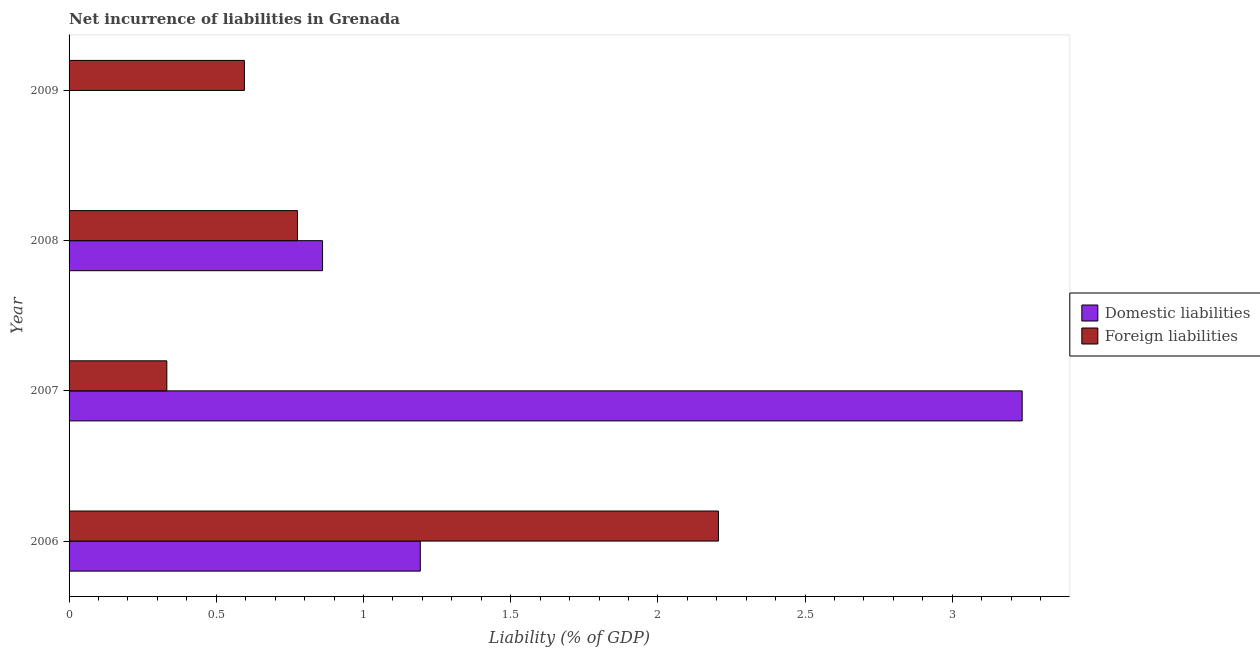How many bars are there on the 1st tick from the top?
Provide a short and direct response. 1. How many bars are there on the 2nd tick from the bottom?
Your response must be concise. 2. What is the label of the 4th group of bars from the top?
Provide a short and direct response. 2006. In how many cases, is the number of bars for a given year not equal to the number of legend labels?
Ensure brevity in your answer.  1. What is the incurrence of foreign liabilities in 2007?
Your answer should be compact. 0.33. Across all years, what is the maximum incurrence of domestic liabilities?
Keep it short and to the point. 3.24. Across all years, what is the minimum incurrence of foreign liabilities?
Your response must be concise. 0.33. In which year was the incurrence of domestic liabilities maximum?
Keep it short and to the point. 2007. What is the total incurrence of foreign liabilities in the graph?
Your answer should be compact. 3.91. What is the difference between the incurrence of foreign liabilities in 2008 and that in 2009?
Provide a short and direct response. 0.18. What is the difference between the incurrence of domestic liabilities in 2006 and the incurrence of foreign liabilities in 2009?
Give a very brief answer. 0.6. What is the average incurrence of foreign liabilities per year?
Offer a very short reply. 0.98. In the year 2008, what is the difference between the incurrence of foreign liabilities and incurrence of domestic liabilities?
Your response must be concise. -0.09. What is the ratio of the incurrence of domestic liabilities in 2006 to that in 2008?
Ensure brevity in your answer.  1.39. What is the difference between the highest and the second highest incurrence of domestic liabilities?
Your answer should be compact. 2.04. What is the difference between the highest and the lowest incurrence of domestic liabilities?
Ensure brevity in your answer.  3.24. Are all the bars in the graph horizontal?
Your answer should be compact. Yes. Are the values on the major ticks of X-axis written in scientific E-notation?
Provide a succinct answer. No. Does the graph contain grids?
Make the answer very short. No. How many legend labels are there?
Provide a short and direct response. 2. How are the legend labels stacked?
Make the answer very short. Vertical. What is the title of the graph?
Offer a terse response. Net incurrence of liabilities in Grenada. Does "Male" appear as one of the legend labels in the graph?
Give a very brief answer. No. What is the label or title of the X-axis?
Give a very brief answer. Liability (% of GDP). What is the Liability (% of GDP) of Domestic liabilities in 2006?
Offer a very short reply. 1.19. What is the Liability (% of GDP) of Foreign liabilities in 2006?
Offer a very short reply. 2.21. What is the Liability (% of GDP) of Domestic liabilities in 2007?
Keep it short and to the point. 3.24. What is the Liability (% of GDP) of Foreign liabilities in 2007?
Provide a succinct answer. 0.33. What is the Liability (% of GDP) of Domestic liabilities in 2008?
Your response must be concise. 0.86. What is the Liability (% of GDP) of Foreign liabilities in 2008?
Offer a terse response. 0.78. What is the Liability (% of GDP) in Foreign liabilities in 2009?
Give a very brief answer. 0.6. Across all years, what is the maximum Liability (% of GDP) of Domestic liabilities?
Your response must be concise. 3.24. Across all years, what is the maximum Liability (% of GDP) in Foreign liabilities?
Make the answer very short. 2.21. Across all years, what is the minimum Liability (% of GDP) of Foreign liabilities?
Your answer should be compact. 0.33. What is the total Liability (% of GDP) in Domestic liabilities in the graph?
Ensure brevity in your answer.  5.29. What is the total Liability (% of GDP) of Foreign liabilities in the graph?
Provide a short and direct response. 3.91. What is the difference between the Liability (% of GDP) of Domestic liabilities in 2006 and that in 2007?
Give a very brief answer. -2.04. What is the difference between the Liability (% of GDP) in Foreign liabilities in 2006 and that in 2007?
Give a very brief answer. 1.87. What is the difference between the Liability (% of GDP) in Domestic liabilities in 2006 and that in 2008?
Provide a short and direct response. 0.33. What is the difference between the Liability (% of GDP) in Foreign liabilities in 2006 and that in 2008?
Ensure brevity in your answer.  1.43. What is the difference between the Liability (% of GDP) in Foreign liabilities in 2006 and that in 2009?
Provide a succinct answer. 1.61. What is the difference between the Liability (% of GDP) in Domestic liabilities in 2007 and that in 2008?
Provide a short and direct response. 2.38. What is the difference between the Liability (% of GDP) of Foreign liabilities in 2007 and that in 2008?
Provide a short and direct response. -0.44. What is the difference between the Liability (% of GDP) of Foreign liabilities in 2007 and that in 2009?
Offer a very short reply. -0.26. What is the difference between the Liability (% of GDP) of Foreign liabilities in 2008 and that in 2009?
Offer a very short reply. 0.18. What is the difference between the Liability (% of GDP) of Domestic liabilities in 2006 and the Liability (% of GDP) of Foreign liabilities in 2007?
Your answer should be compact. 0.86. What is the difference between the Liability (% of GDP) in Domestic liabilities in 2006 and the Liability (% of GDP) in Foreign liabilities in 2008?
Offer a terse response. 0.42. What is the difference between the Liability (% of GDP) in Domestic liabilities in 2006 and the Liability (% of GDP) in Foreign liabilities in 2009?
Your answer should be compact. 0.6. What is the difference between the Liability (% of GDP) in Domestic liabilities in 2007 and the Liability (% of GDP) in Foreign liabilities in 2008?
Give a very brief answer. 2.46. What is the difference between the Liability (% of GDP) in Domestic liabilities in 2007 and the Liability (% of GDP) in Foreign liabilities in 2009?
Provide a succinct answer. 2.64. What is the difference between the Liability (% of GDP) of Domestic liabilities in 2008 and the Liability (% of GDP) of Foreign liabilities in 2009?
Make the answer very short. 0.27. What is the average Liability (% of GDP) in Domestic liabilities per year?
Offer a terse response. 1.32. What is the average Liability (% of GDP) in Foreign liabilities per year?
Offer a very short reply. 0.98. In the year 2006, what is the difference between the Liability (% of GDP) of Domestic liabilities and Liability (% of GDP) of Foreign liabilities?
Make the answer very short. -1.01. In the year 2007, what is the difference between the Liability (% of GDP) in Domestic liabilities and Liability (% of GDP) in Foreign liabilities?
Provide a succinct answer. 2.91. In the year 2008, what is the difference between the Liability (% of GDP) of Domestic liabilities and Liability (% of GDP) of Foreign liabilities?
Your response must be concise. 0.09. What is the ratio of the Liability (% of GDP) of Domestic liabilities in 2006 to that in 2007?
Keep it short and to the point. 0.37. What is the ratio of the Liability (% of GDP) in Foreign liabilities in 2006 to that in 2007?
Keep it short and to the point. 6.64. What is the ratio of the Liability (% of GDP) in Domestic liabilities in 2006 to that in 2008?
Make the answer very short. 1.39. What is the ratio of the Liability (% of GDP) in Foreign liabilities in 2006 to that in 2008?
Offer a terse response. 2.84. What is the ratio of the Liability (% of GDP) in Foreign liabilities in 2006 to that in 2009?
Ensure brevity in your answer.  3.7. What is the ratio of the Liability (% of GDP) of Domestic liabilities in 2007 to that in 2008?
Provide a succinct answer. 3.76. What is the ratio of the Liability (% of GDP) of Foreign liabilities in 2007 to that in 2008?
Your answer should be very brief. 0.43. What is the ratio of the Liability (% of GDP) of Foreign liabilities in 2007 to that in 2009?
Make the answer very short. 0.56. What is the ratio of the Liability (% of GDP) in Foreign liabilities in 2008 to that in 2009?
Offer a terse response. 1.3. What is the difference between the highest and the second highest Liability (% of GDP) of Domestic liabilities?
Offer a terse response. 2.04. What is the difference between the highest and the second highest Liability (% of GDP) of Foreign liabilities?
Give a very brief answer. 1.43. What is the difference between the highest and the lowest Liability (% of GDP) in Domestic liabilities?
Your answer should be compact. 3.24. What is the difference between the highest and the lowest Liability (% of GDP) of Foreign liabilities?
Make the answer very short. 1.87. 